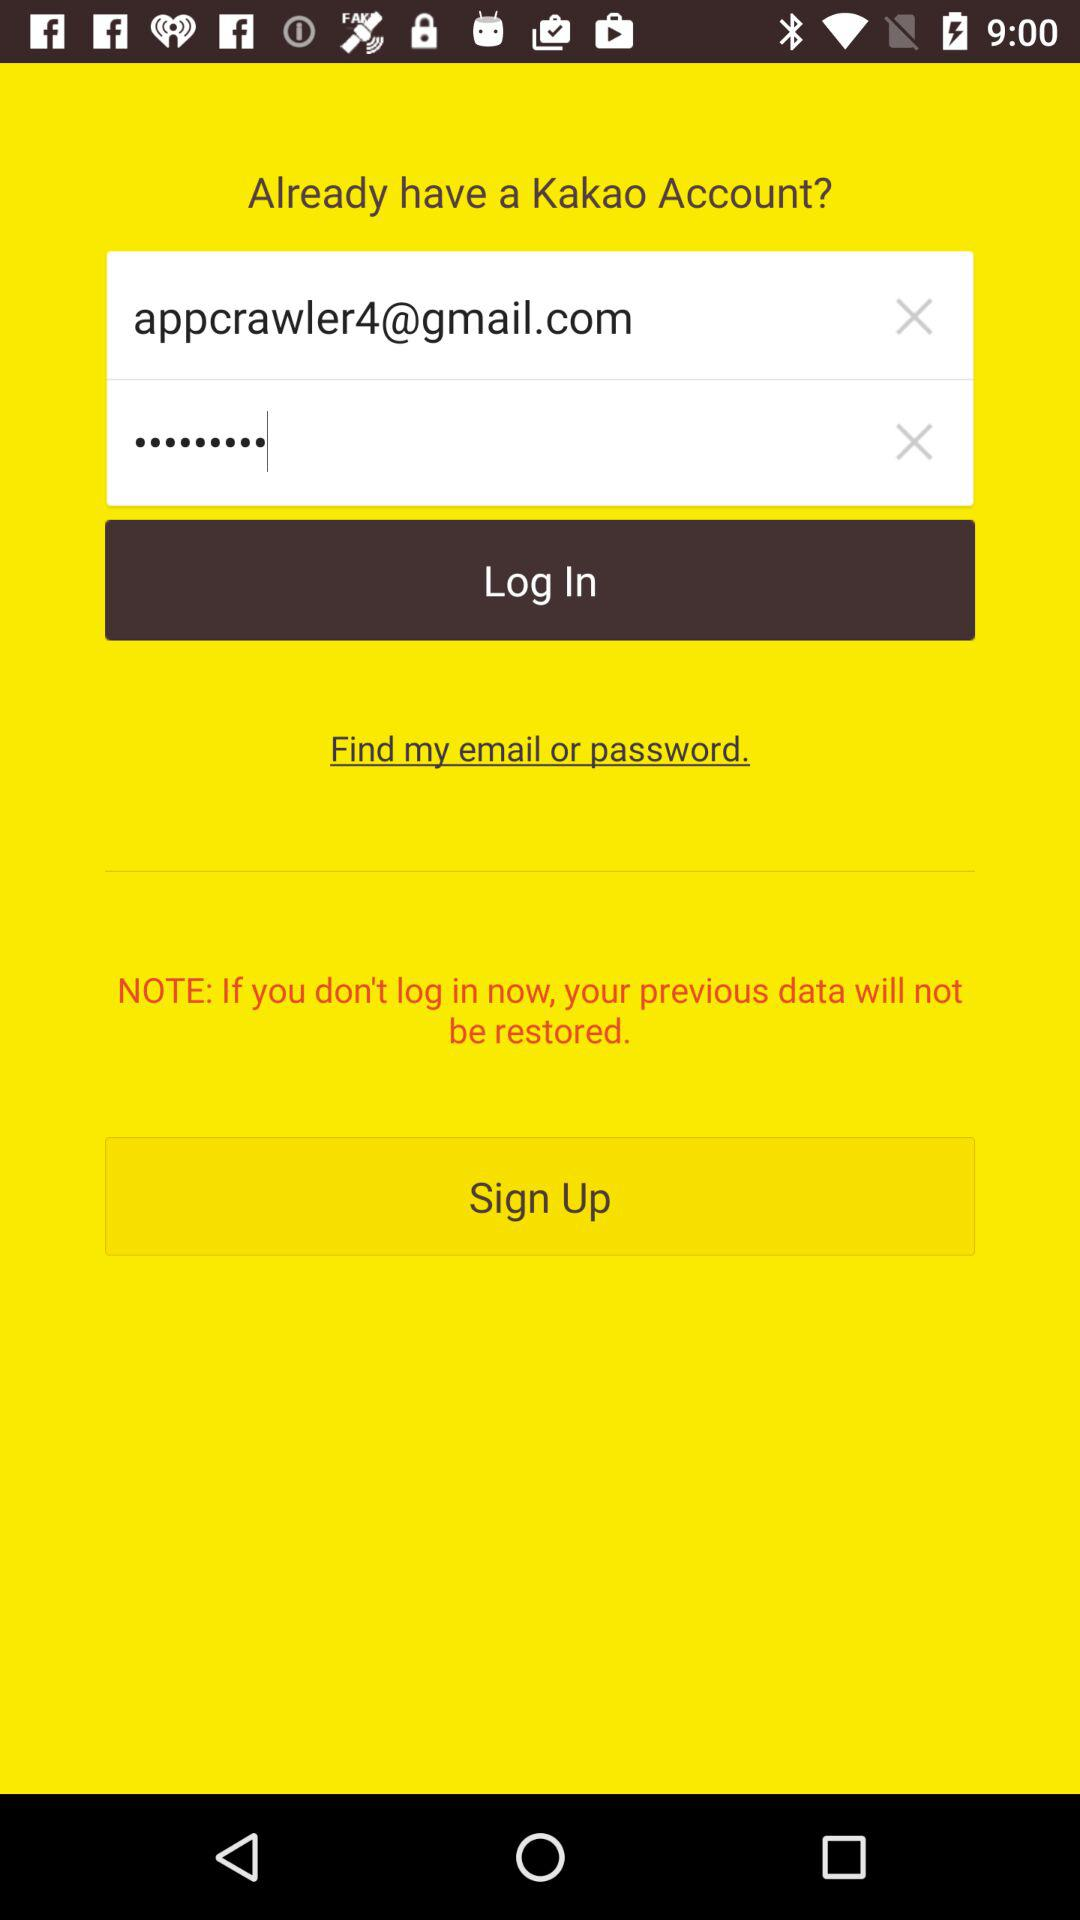How many characters are required for the password?
When the provided information is insufficient, respond with <no answer>. <no answer> 